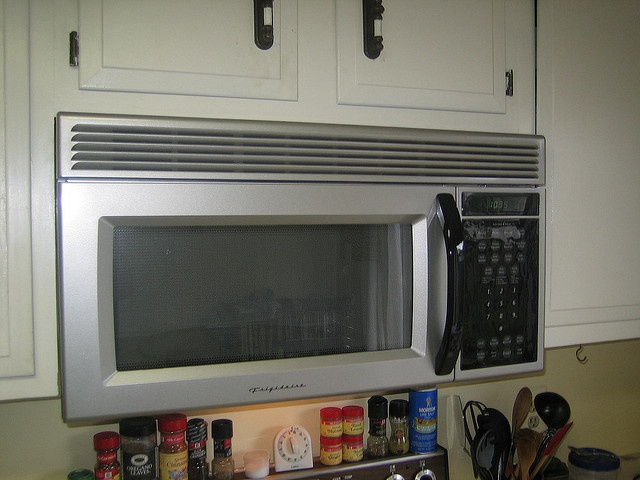Describe the objects in this image and their specific colors. I can see microwave in gray, black, darkgray, and lightgray tones, oven in gray, black, and darkgray tones, bottle in gray and black tones, bottle in gray, maroon, black, and olive tones, and clock in gray and darkgray tones in this image. 